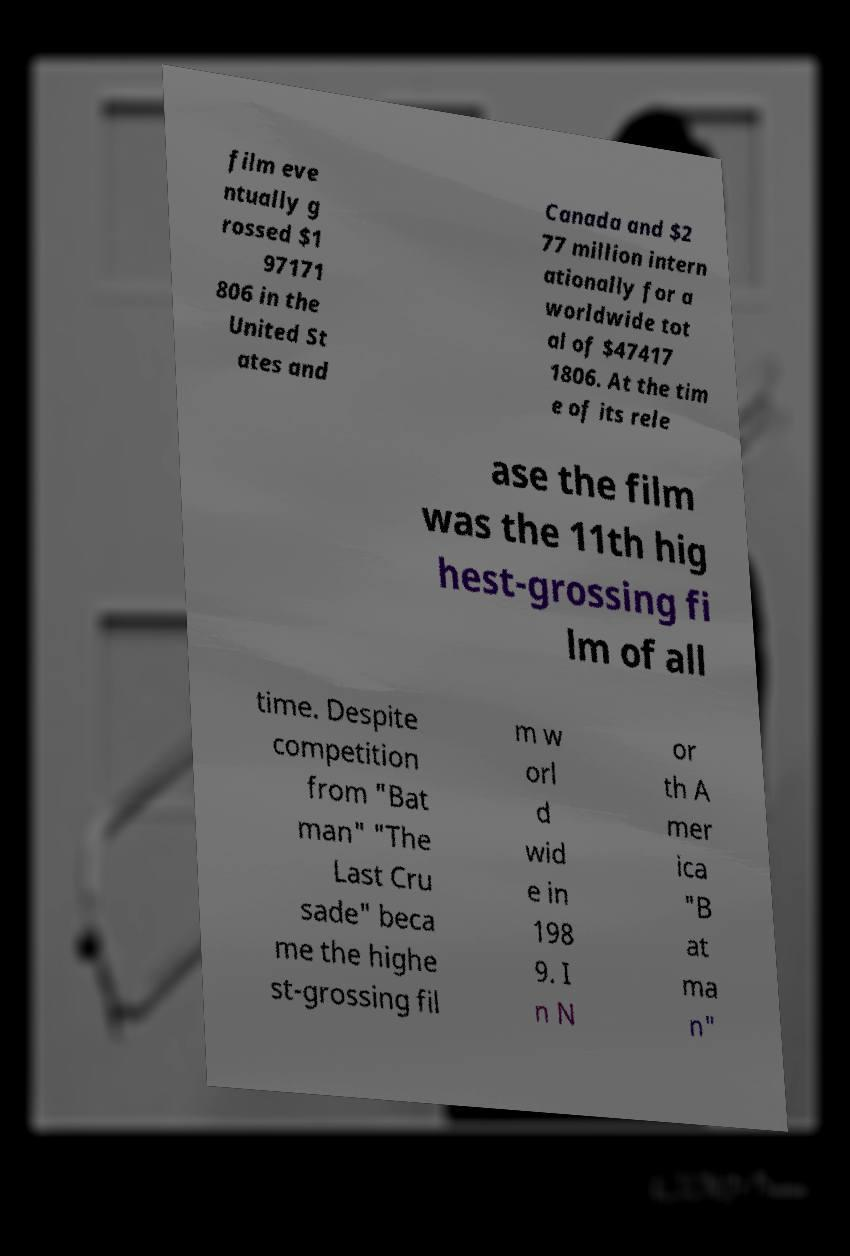What messages or text are displayed in this image? I need them in a readable, typed format. film eve ntually g rossed $1 97171 806 in the United St ates and Canada and $2 77 million intern ationally for a worldwide tot al of $47417 1806. At the tim e of its rele ase the film was the 11th hig hest-grossing fi lm of all time. Despite competition from "Bat man" "The Last Cru sade" beca me the highe st-grossing fil m w orl d wid e in 198 9. I n N or th A mer ica "B at ma n" 